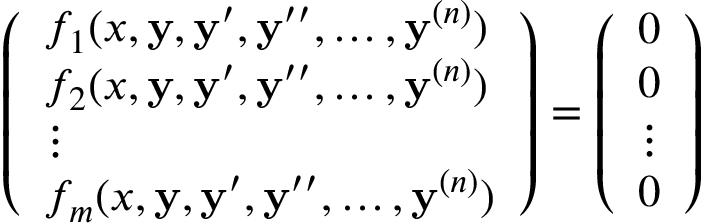Convert formula to latex. <formula><loc_0><loc_0><loc_500><loc_500>{ \left ( \begin{array} { l } { f _ { 1 } ( x , y , y ^ { \prime } , y ^ { \prime \prime } , \dots , y ^ { ( n ) } ) } \\ { f _ { 2 } ( x , y , y ^ { \prime } , y ^ { \prime \prime } , \dots , y ^ { ( n ) } ) } \\ { \vdots } \\ { f _ { m } ( x , y , y ^ { \prime } , y ^ { \prime \prime } , \dots , y ^ { ( n ) } ) } \end{array} \right ) } = { \left ( \begin{array} { l } { 0 } \\ { 0 } \\ { \vdots } \\ { 0 } \end{array} \right ) }</formula> 